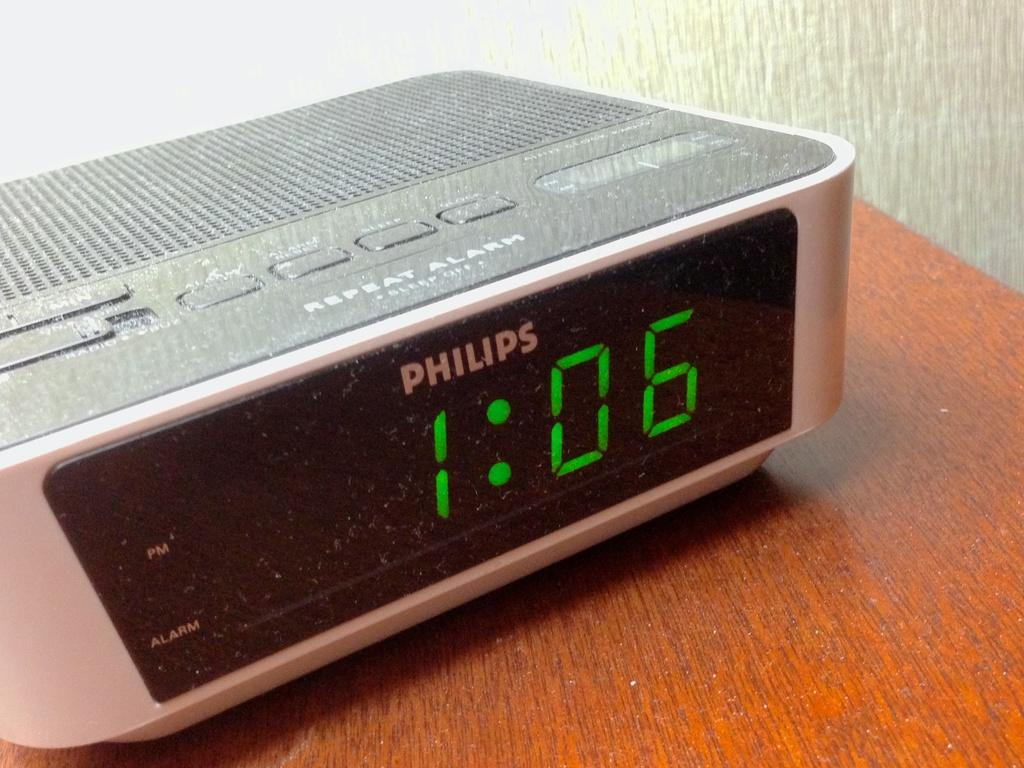<image>
Describe the image concisely. A gray Philips alarm clock shows the time on the wooden table. 